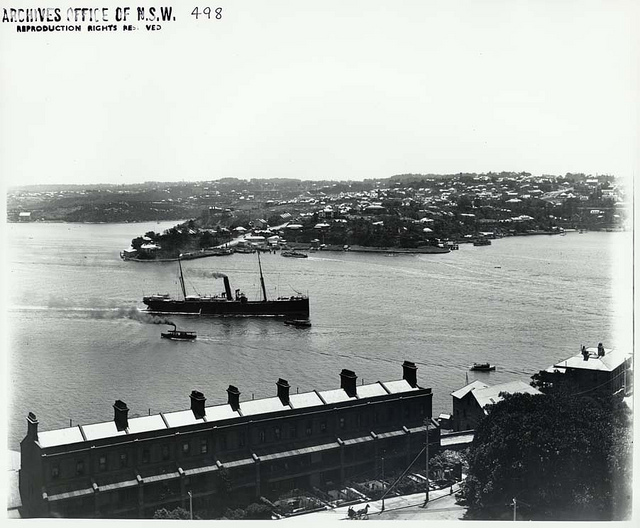Please extract the text content from this image. ARCHIVES OFFICE OF N S VED RIGHTS REPRODUCTION 498 W 